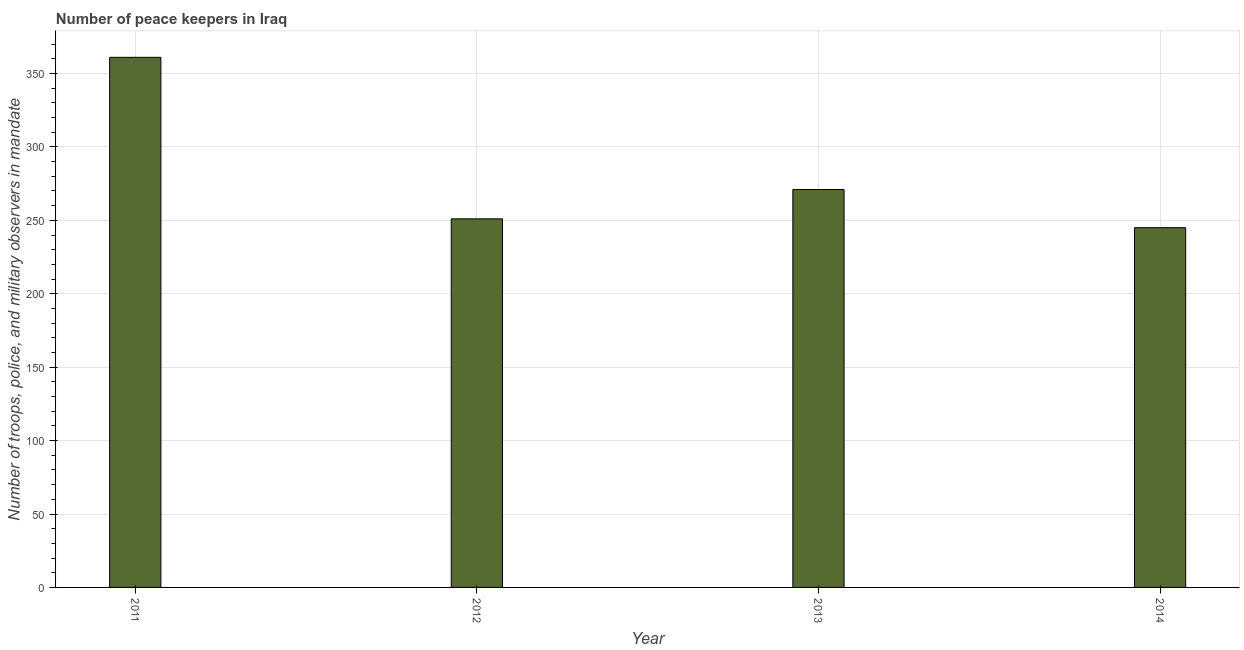Does the graph contain any zero values?
Keep it short and to the point. No. Does the graph contain grids?
Give a very brief answer. Yes. What is the title of the graph?
Your answer should be very brief. Number of peace keepers in Iraq. What is the label or title of the X-axis?
Your answer should be very brief. Year. What is the label or title of the Y-axis?
Your answer should be compact. Number of troops, police, and military observers in mandate. What is the number of peace keepers in 2014?
Offer a very short reply. 245. Across all years, what is the maximum number of peace keepers?
Your response must be concise. 361. Across all years, what is the minimum number of peace keepers?
Keep it short and to the point. 245. In which year was the number of peace keepers minimum?
Ensure brevity in your answer.  2014. What is the sum of the number of peace keepers?
Make the answer very short. 1128. What is the difference between the number of peace keepers in 2011 and 2014?
Your answer should be very brief. 116. What is the average number of peace keepers per year?
Your answer should be compact. 282. What is the median number of peace keepers?
Your response must be concise. 261. In how many years, is the number of peace keepers greater than 120 ?
Give a very brief answer. 4. Do a majority of the years between 2014 and 2013 (inclusive) have number of peace keepers greater than 160 ?
Keep it short and to the point. No. What is the ratio of the number of peace keepers in 2011 to that in 2012?
Ensure brevity in your answer.  1.44. Is the difference between the number of peace keepers in 2013 and 2014 greater than the difference between any two years?
Provide a short and direct response. No. What is the difference between the highest and the lowest number of peace keepers?
Provide a succinct answer. 116. In how many years, is the number of peace keepers greater than the average number of peace keepers taken over all years?
Your answer should be compact. 1. Are all the bars in the graph horizontal?
Keep it short and to the point. No. How many years are there in the graph?
Offer a terse response. 4. What is the Number of troops, police, and military observers in mandate of 2011?
Your response must be concise. 361. What is the Number of troops, police, and military observers in mandate of 2012?
Provide a short and direct response. 251. What is the Number of troops, police, and military observers in mandate of 2013?
Your answer should be compact. 271. What is the Number of troops, police, and military observers in mandate in 2014?
Keep it short and to the point. 245. What is the difference between the Number of troops, police, and military observers in mandate in 2011 and 2012?
Offer a terse response. 110. What is the difference between the Number of troops, police, and military observers in mandate in 2011 and 2013?
Your answer should be compact. 90. What is the difference between the Number of troops, police, and military observers in mandate in 2011 and 2014?
Your answer should be compact. 116. What is the difference between the Number of troops, police, and military observers in mandate in 2012 and 2014?
Keep it short and to the point. 6. What is the ratio of the Number of troops, police, and military observers in mandate in 2011 to that in 2012?
Give a very brief answer. 1.44. What is the ratio of the Number of troops, police, and military observers in mandate in 2011 to that in 2013?
Provide a short and direct response. 1.33. What is the ratio of the Number of troops, police, and military observers in mandate in 2011 to that in 2014?
Offer a very short reply. 1.47. What is the ratio of the Number of troops, police, and military observers in mandate in 2012 to that in 2013?
Provide a succinct answer. 0.93. What is the ratio of the Number of troops, police, and military observers in mandate in 2013 to that in 2014?
Keep it short and to the point. 1.11. 